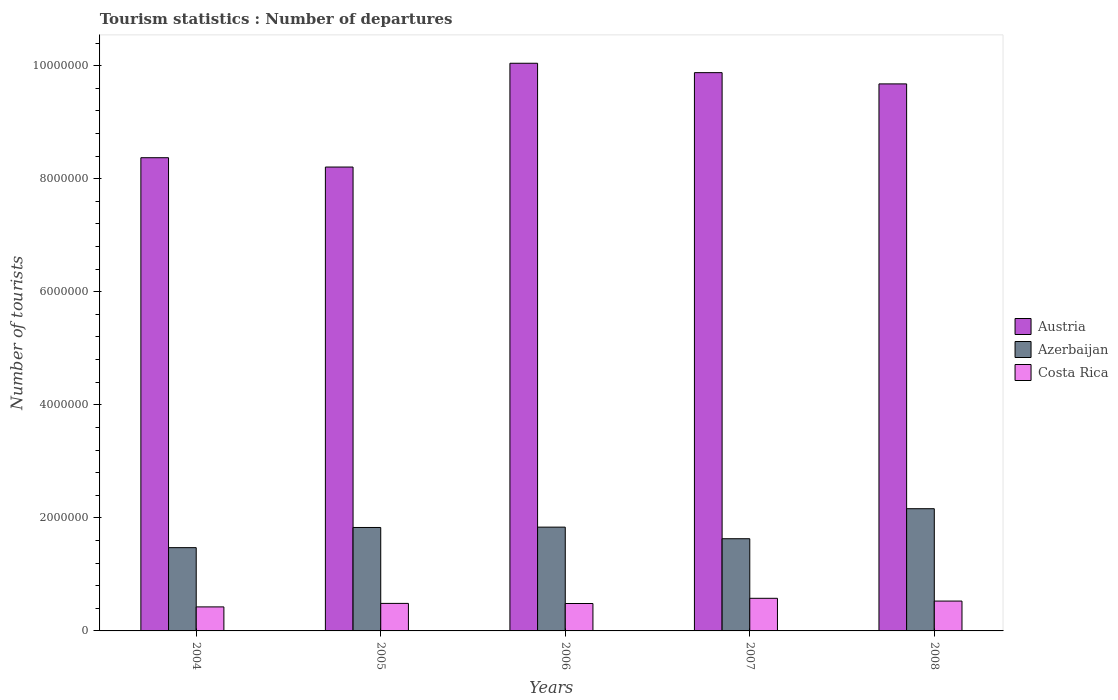How many different coloured bars are there?
Provide a succinct answer. 3. Are the number of bars per tick equal to the number of legend labels?
Offer a very short reply. Yes. Are the number of bars on each tick of the X-axis equal?
Offer a very short reply. Yes. How many bars are there on the 3rd tick from the left?
Provide a succinct answer. 3. What is the number of tourist departures in Costa Rica in 2004?
Make the answer very short. 4.25e+05. Across all years, what is the maximum number of tourist departures in Azerbaijan?
Make the answer very short. 2.16e+06. Across all years, what is the minimum number of tourist departures in Azerbaijan?
Make the answer very short. 1.47e+06. In which year was the number of tourist departures in Costa Rica maximum?
Keep it short and to the point. 2007. In which year was the number of tourist departures in Austria minimum?
Keep it short and to the point. 2005. What is the total number of tourist departures in Azerbaijan in the graph?
Your response must be concise. 8.93e+06. What is the difference between the number of tourist departures in Costa Rica in 2005 and that in 2007?
Provide a succinct answer. -9.00e+04. What is the difference between the number of tourist departures in Austria in 2008 and the number of tourist departures in Costa Rica in 2005?
Offer a very short reply. 9.19e+06. What is the average number of tourist departures in Azerbaijan per year?
Offer a terse response. 1.79e+06. In the year 2004, what is the difference between the number of tourist departures in Austria and number of tourist departures in Azerbaijan?
Your answer should be compact. 6.90e+06. What is the ratio of the number of tourist departures in Costa Rica in 2005 to that in 2007?
Provide a succinct answer. 0.84. Is the number of tourist departures in Austria in 2004 less than that in 2006?
Keep it short and to the point. Yes. Is the difference between the number of tourist departures in Austria in 2004 and 2008 greater than the difference between the number of tourist departures in Azerbaijan in 2004 and 2008?
Your answer should be compact. No. What is the difference between the highest and the second highest number of tourist departures in Azerbaijan?
Your answer should be compact. 3.26e+05. What is the difference between the highest and the lowest number of tourist departures in Austria?
Your response must be concise. 1.84e+06. What does the 2nd bar from the left in 2006 represents?
Give a very brief answer. Azerbaijan. What does the 2nd bar from the right in 2007 represents?
Provide a succinct answer. Azerbaijan. How many bars are there?
Keep it short and to the point. 15. Are all the bars in the graph horizontal?
Provide a short and direct response. No. What is the difference between two consecutive major ticks on the Y-axis?
Make the answer very short. 2.00e+06. Does the graph contain any zero values?
Your response must be concise. No. Where does the legend appear in the graph?
Give a very brief answer. Center right. What is the title of the graph?
Provide a short and direct response. Tourism statistics : Number of departures. What is the label or title of the Y-axis?
Your answer should be very brief. Number of tourists. What is the Number of tourists in Austria in 2004?
Offer a terse response. 8.37e+06. What is the Number of tourists in Azerbaijan in 2004?
Give a very brief answer. 1.47e+06. What is the Number of tourists of Costa Rica in 2004?
Your response must be concise. 4.25e+05. What is the Number of tourists of Austria in 2005?
Offer a very short reply. 8.21e+06. What is the Number of tourists of Azerbaijan in 2005?
Offer a terse response. 1.83e+06. What is the Number of tourists of Costa Rica in 2005?
Keep it short and to the point. 4.87e+05. What is the Number of tourists of Austria in 2006?
Offer a terse response. 1.00e+07. What is the Number of tourists of Azerbaijan in 2006?
Offer a very short reply. 1.84e+06. What is the Number of tourists in Costa Rica in 2006?
Your response must be concise. 4.85e+05. What is the Number of tourists of Austria in 2007?
Your answer should be very brief. 9.88e+06. What is the Number of tourists of Azerbaijan in 2007?
Provide a succinct answer. 1.63e+06. What is the Number of tourists in Costa Rica in 2007?
Offer a terse response. 5.77e+05. What is the Number of tourists in Austria in 2008?
Keep it short and to the point. 9.68e+06. What is the Number of tourists of Azerbaijan in 2008?
Ensure brevity in your answer.  2.16e+06. What is the Number of tourists of Costa Rica in 2008?
Offer a terse response. 5.28e+05. Across all years, what is the maximum Number of tourists of Austria?
Your response must be concise. 1.00e+07. Across all years, what is the maximum Number of tourists of Azerbaijan?
Ensure brevity in your answer.  2.16e+06. Across all years, what is the maximum Number of tourists of Costa Rica?
Offer a very short reply. 5.77e+05. Across all years, what is the minimum Number of tourists in Austria?
Provide a succinct answer. 8.21e+06. Across all years, what is the minimum Number of tourists of Azerbaijan?
Keep it short and to the point. 1.47e+06. Across all years, what is the minimum Number of tourists in Costa Rica?
Give a very brief answer. 4.25e+05. What is the total Number of tourists in Austria in the graph?
Your answer should be compact. 4.62e+07. What is the total Number of tourists in Azerbaijan in the graph?
Make the answer very short. 8.93e+06. What is the total Number of tourists of Costa Rica in the graph?
Your answer should be very brief. 2.50e+06. What is the difference between the Number of tourists in Austria in 2004 and that in 2005?
Make the answer very short. 1.65e+05. What is the difference between the Number of tourists in Azerbaijan in 2004 and that in 2005?
Your answer should be very brief. -3.57e+05. What is the difference between the Number of tourists in Costa Rica in 2004 and that in 2005?
Make the answer very short. -6.20e+04. What is the difference between the Number of tourists in Austria in 2004 and that in 2006?
Give a very brief answer. -1.67e+06. What is the difference between the Number of tourists of Azerbaijan in 2004 and that in 2006?
Offer a very short reply. -3.63e+05. What is the difference between the Number of tourists in Austria in 2004 and that in 2007?
Offer a terse response. -1.50e+06. What is the difference between the Number of tourists of Azerbaijan in 2004 and that in 2007?
Keep it short and to the point. -1.58e+05. What is the difference between the Number of tourists in Costa Rica in 2004 and that in 2007?
Your answer should be compact. -1.52e+05. What is the difference between the Number of tourists in Austria in 2004 and that in 2008?
Provide a succinct answer. -1.31e+06. What is the difference between the Number of tourists in Azerbaijan in 2004 and that in 2008?
Provide a short and direct response. -6.89e+05. What is the difference between the Number of tourists of Costa Rica in 2004 and that in 2008?
Give a very brief answer. -1.03e+05. What is the difference between the Number of tourists of Austria in 2005 and that in 2006?
Provide a short and direct response. -1.84e+06. What is the difference between the Number of tourists of Azerbaijan in 2005 and that in 2006?
Provide a succinct answer. -6000. What is the difference between the Number of tourists of Austria in 2005 and that in 2007?
Provide a short and direct response. -1.67e+06. What is the difference between the Number of tourists in Azerbaijan in 2005 and that in 2007?
Offer a terse response. 1.99e+05. What is the difference between the Number of tourists of Austria in 2005 and that in 2008?
Provide a succinct answer. -1.47e+06. What is the difference between the Number of tourists of Azerbaijan in 2005 and that in 2008?
Offer a terse response. -3.32e+05. What is the difference between the Number of tourists of Costa Rica in 2005 and that in 2008?
Make the answer very short. -4.10e+04. What is the difference between the Number of tourists in Austria in 2006 and that in 2007?
Make the answer very short. 1.66e+05. What is the difference between the Number of tourists of Azerbaijan in 2006 and that in 2007?
Provide a short and direct response. 2.05e+05. What is the difference between the Number of tourists in Costa Rica in 2006 and that in 2007?
Your answer should be very brief. -9.20e+04. What is the difference between the Number of tourists of Austria in 2006 and that in 2008?
Your answer should be very brief. 3.65e+05. What is the difference between the Number of tourists of Azerbaijan in 2006 and that in 2008?
Provide a succinct answer. -3.26e+05. What is the difference between the Number of tourists of Costa Rica in 2006 and that in 2008?
Offer a terse response. -4.30e+04. What is the difference between the Number of tourists of Austria in 2007 and that in 2008?
Provide a short and direct response. 1.99e+05. What is the difference between the Number of tourists in Azerbaijan in 2007 and that in 2008?
Your answer should be very brief. -5.31e+05. What is the difference between the Number of tourists of Costa Rica in 2007 and that in 2008?
Your answer should be compact. 4.90e+04. What is the difference between the Number of tourists of Austria in 2004 and the Number of tourists of Azerbaijan in 2005?
Ensure brevity in your answer.  6.54e+06. What is the difference between the Number of tourists in Austria in 2004 and the Number of tourists in Costa Rica in 2005?
Offer a very short reply. 7.88e+06. What is the difference between the Number of tourists of Azerbaijan in 2004 and the Number of tourists of Costa Rica in 2005?
Offer a terse response. 9.86e+05. What is the difference between the Number of tourists of Austria in 2004 and the Number of tourists of Azerbaijan in 2006?
Make the answer very short. 6.54e+06. What is the difference between the Number of tourists in Austria in 2004 and the Number of tourists in Costa Rica in 2006?
Make the answer very short. 7.89e+06. What is the difference between the Number of tourists in Azerbaijan in 2004 and the Number of tourists in Costa Rica in 2006?
Offer a very short reply. 9.88e+05. What is the difference between the Number of tourists of Austria in 2004 and the Number of tourists of Azerbaijan in 2007?
Keep it short and to the point. 6.74e+06. What is the difference between the Number of tourists in Austria in 2004 and the Number of tourists in Costa Rica in 2007?
Make the answer very short. 7.79e+06. What is the difference between the Number of tourists in Azerbaijan in 2004 and the Number of tourists in Costa Rica in 2007?
Provide a short and direct response. 8.96e+05. What is the difference between the Number of tourists of Austria in 2004 and the Number of tourists of Azerbaijan in 2008?
Give a very brief answer. 6.21e+06. What is the difference between the Number of tourists of Austria in 2004 and the Number of tourists of Costa Rica in 2008?
Offer a very short reply. 7.84e+06. What is the difference between the Number of tourists of Azerbaijan in 2004 and the Number of tourists of Costa Rica in 2008?
Offer a very short reply. 9.45e+05. What is the difference between the Number of tourists in Austria in 2005 and the Number of tourists in Azerbaijan in 2006?
Your answer should be compact. 6.37e+06. What is the difference between the Number of tourists in Austria in 2005 and the Number of tourists in Costa Rica in 2006?
Your answer should be compact. 7.72e+06. What is the difference between the Number of tourists of Azerbaijan in 2005 and the Number of tourists of Costa Rica in 2006?
Your answer should be very brief. 1.34e+06. What is the difference between the Number of tourists of Austria in 2005 and the Number of tourists of Azerbaijan in 2007?
Your response must be concise. 6.58e+06. What is the difference between the Number of tourists in Austria in 2005 and the Number of tourists in Costa Rica in 2007?
Your answer should be compact. 7.63e+06. What is the difference between the Number of tourists of Azerbaijan in 2005 and the Number of tourists of Costa Rica in 2007?
Provide a succinct answer. 1.25e+06. What is the difference between the Number of tourists in Austria in 2005 and the Number of tourists in Azerbaijan in 2008?
Offer a very short reply. 6.04e+06. What is the difference between the Number of tourists of Austria in 2005 and the Number of tourists of Costa Rica in 2008?
Offer a very short reply. 7.68e+06. What is the difference between the Number of tourists of Azerbaijan in 2005 and the Number of tourists of Costa Rica in 2008?
Ensure brevity in your answer.  1.30e+06. What is the difference between the Number of tourists in Austria in 2006 and the Number of tourists in Azerbaijan in 2007?
Your answer should be very brief. 8.41e+06. What is the difference between the Number of tourists of Austria in 2006 and the Number of tourists of Costa Rica in 2007?
Keep it short and to the point. 9.46e+06. What is the difference between the Number of tourists of Azerbaijan in 2006 and the Number of tourists of Costa Rica in 2007?
Provide a succinct answer. 1.26e+06. What is the difference between the Number of tourists of Austria in 2006 and the Number of tourists of Azerbaijan in 2008?
Provide a succinct answer. 7.88e+06. What is the difference between the Number of tourists in Austria in 2006 and the Number of tourists in Costa Rica in 2008?
Give a very brief answer. 9.51e+06. What is the difference between the Number of tourists of Azerbaijan in 2006 and the Number of tourists of Costa Rica in 2008?
Make the answer very short. 1.31e+06. What is the difference between the Number of tourists in Austria in 2007 and the Number of tourists in Azerbaijan in 2008?
Ensure brevity in your answer.  7.71e+06. What is the difference between the Number of tourists of Austria in 2007 and the Number of tourists of Costa Rica in 2008?
Your response must be concise. 9.35e+06. What is the difference between the Number of tourists of Azerbaijan in 2007 and the Number of tourists of Costa Rica in 2008?
Offer a very short reply. 1.10e+06. What is the average Number of tourists in Austria per year?
Provide a succinct answer. 9.23e+06. What is the average Number of tourists in Azerbaijan per year?
Give a very brief answer. 1.79e+06. What is the average Number of tourists of Costa Rica per year?
Keep it short and to the point. 5.00e+05. In the year 2004, what is the difference between the Number of tourists of Austria and Number of tourists of Azerbaijan?
Make the answer very short. 6.90e+06. In the year 2004, what is the difference between the Number of tourists in Austria and Number of tourists in Costa Rica?
Provide a short and direct response. 7.95e+06. In the year 2004, what is the difference between the Number of tourists of Azerbaijan and Number of tourists of Costa Rica?
Give a very brief answer. 1.05e+06. In the year 2005, what is the difference between the Number of tourists in Austria and Number of tourists in Azerbaijan?
Your answer should be very brief. 6.38e+06. In the year 2005, what is the difference between the Number of tourists of Austria and Number of tourists of Costa Rica?
Make the answer very short. 7.72e+06. In the year 2005, what is the difference between the Number of tourists in Azerbaijan and Number of tourists in Costa Rica?
Ensure brevity in your answer.  1.34e+06. In the year 2006, what is the difference between the Number of tourists in Austria and Number of tourists in Azerbaijan?
Keep it short and to the point. 8.21e+06. In the year 2006, what is the difference between the Number of tourists in Austria and Number of tourists in Costa Rica?
Make the answer very short. 9.56e+06. In the year 2006, what is the difference between the Number of tourists in Azerbaijan and Number of tourists in Costa Rica?
Your response must be concise. 1.35e+06. In the year 2007, what is the difference between the Number of tourists in Austria and Number of tourists in Azerbaijan?
Keep it short and to the point. 8.24e+06. In the year 2007, what is the difference between the Number of tourists of Austria and Number of tourists of Costa Rica?
Your response must be concise. 9.30e+06. In the year 2007, what is the difference between the Number of tourists of Azerbaijan and Number of tourists of Costa Rica?
Offer a very short reply. 1.05e+06. In the year 2008, what is the difference between the Number of tourists of Austria and Number of tourists of Azerbaijan?
Give a very brief answer. 7.52e+06. In the year 2008, what is the difference between the Number of tourists in Austria and Number of tourists in Costa Rica?
Provide a short and direct response. 9.15e+06. In the year 2008, what is the difference between the Number of tourists in Azerbaijan and Number of tourists in Costa Rica?
Keep it short and to the point. 1.63e+06. What is the ratio of the Number of tourists in Austria in 2004 to that in 2005?
Keep it short and to the point. 1.02. What is the ratio of the Number of tourists in Azerbaijan in 2004 to that in 2005?
Your answer should be very brief. 0.8. What is the ratio of the Number of tourists of Costa Rica in 2004 to that in 2005?
Your response must be concise. 0.87. What is the ratio of the Number of tourists of Austria in 2004 to that in 2006?
Your response must be concise. 0.83. What is the ratio of the Number of tourists in Azerbaijan in 2004 to that in 2006?
Offer a very short reply. 0.8. What is the ratio of the Number of tourists in Costa Rica in 2004 to that in 2006?
Offer a terse response. 0.88. What is the ratio of the Number of tourists in Austria in 2004 to that in 2007?
Provide a short and direct response. 0.85. What is the ratio of the Number of tourists in Azerbaijan in 2004 to that in 2007?
Offer a very short reply. 0.9. What is the ratio of the Number of tourists of Costa Rica in 2004 to that in 2007?
Offer a very short reply. 0.74. What is the ratio of the Number of tourists in Austria in 2004 to that in 2008?
Offer a terse response. 0.86. What is the ratio of the Number of tourists in Azerbaijan in 2004 to that in 2008?
Give a very brief answer. 0.68. What is the ratio of the Number of tourists of Costa Rica in 2004 to that in 2008?
Make the answer very short. 0.8. What is the ratio of the Number of tourists of Austria in 2005 to that in 2006?
Provide a succinct answer. 0.82. What is the ratio of the Number of tourists of Azerbaijan in 2005 to that in 2006?
Your response must be concise. 1. What is the ratio of the Number of tourists in Austria in 2005 to that in 2007?
Your response must be concise. 0.83. What is the ratio of the Number of tourists in Azerbaijan in 2005 to that in 2007?
Make the answer very short. 1.12. What is the ratio of the Number of tourists of Costa Rica in 2005 to that in 2007?
Make the answer very short. 0.84. What is the ratio of the Number of tourists of Austria in 2005 to that in 2008?
Provide a succinct answer. 0.85. What is the ratio of the Number of tourists of Azerbaijan in 2005 to that in 2008?
Provide a short and direct response. 0.85. What is the ratio of the Number of tourists in Costa Rica in 2005 to that in 2008?
Provide a short and direct response. 0.92. What is the ratio of the Number of tourists of Austria in 2006 to that in 2007?
Keep it short and to the point. 1.02. What is the ratio of the Number of tourists of Azerbaijan in 2006 to that in 2007?
Give a very brief answer. 1.13. What is the ratio of the Number of tourists in Costa Rica in 2006 to that in 2007?
Keep it short and to the point. 0.84. What is the ratio of the Number of tourists of Austria in 2006 to that in 2008?
Your response must be concise. 1.04. What is the ratio of the Number of tourists of Azerbaijan in 2006 to that in 2008?
Your response must be concise. 0.85. What is the ratio of the Number of tourists of Costa Rica in 2006 to that in 2008?
Offer a very short reply. 0.92. What is the ratio of the Number of tourists of Austria in 2007 to that in 2008?
Keep it short and to the point. 1.02. What is the ratio of the Number of tourists of Azerbaijan in 2007 to that in 2008?
Make the answer very short. 0.75. What is the ratio of the Number of tourists in Costa Rica in 2007 to that in 2008?
Your answer should be very brief. 1.09. What is the difference between the highest and the second highest Number of tourists in Austria?
Make the answer very short. 1.66e+05. What is the difference between the highest and the second highest Number of tourists of Azerbaijan?
Provide a succinct answer. 3.26e+05. What is the difference between the highest and the second highest Number of tourists in Costa Rica?
Offer a terse response. 4.90e+04. What is the difference between the highest and the lowest Number of tourists in Austria?
Your answer should be very brief. 1.84e+06. What is the difference between the highest and the lowest Number of tourists of Azerbaijan?
Offer a very short reply. 6.89e+05. What is the difference between the highest and the lowest Number of tourists of Costa Rica?
Offer a very short reply. 1.52e+05. 